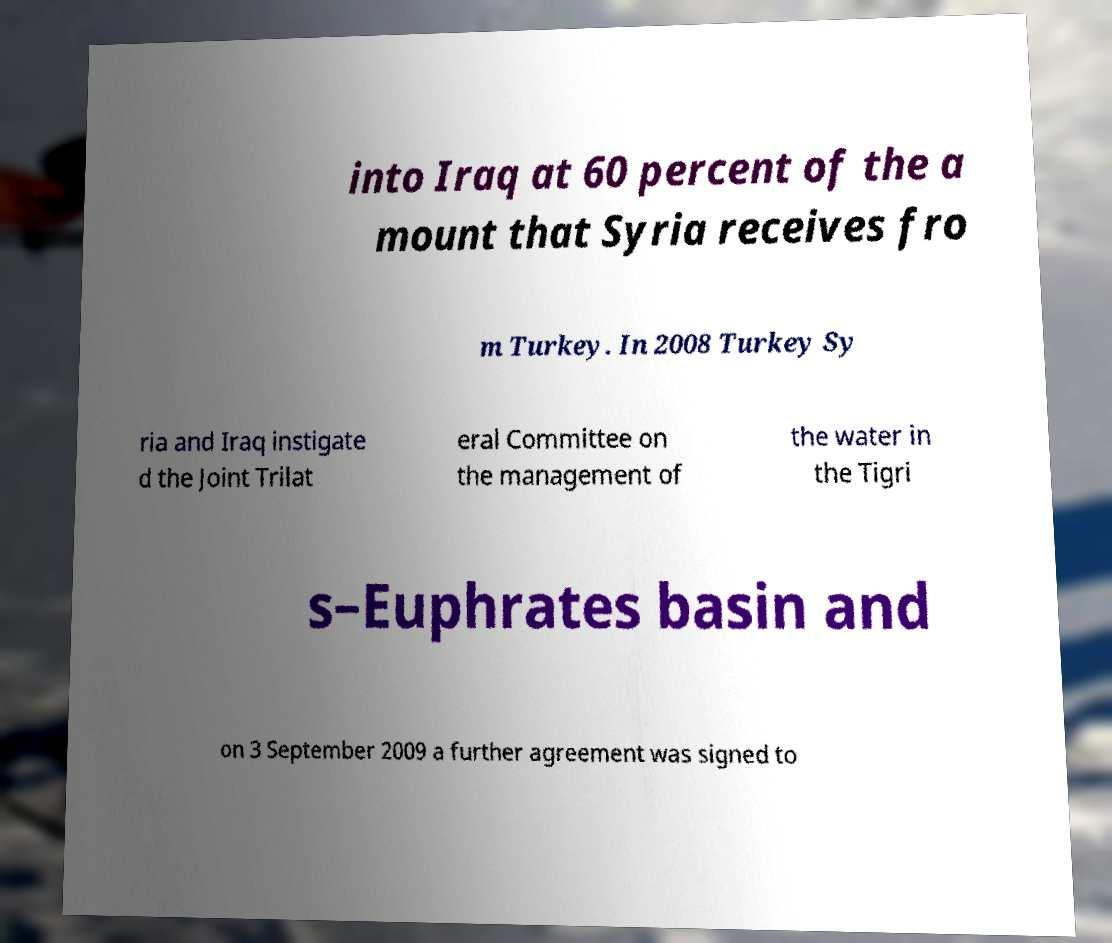Can you read and provide the text displayed in the image?This photo seems to have some interesting text. Can you extract and type it out for me? into Iraq at 60 percent of the a mount that Syria receives fro m Turkey. In 2008 Turkey Sy ria and Iraq instigate d the Joint Trilat eral Committee on the management of the water in the Tigri s–Euphrates basin and on 3 September 2009 a further agreement was signed to 